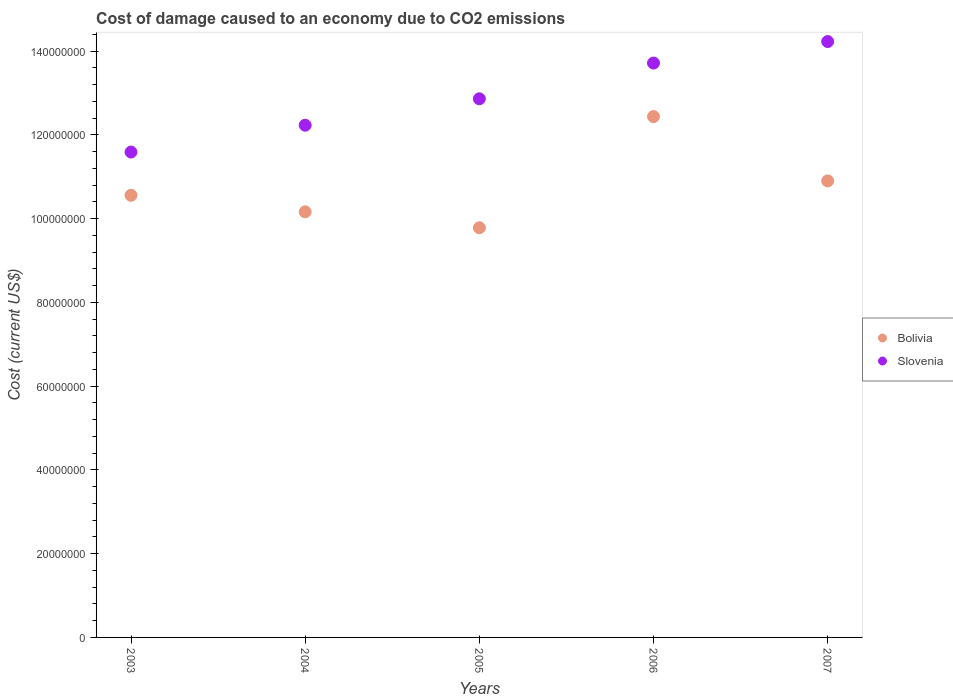How many different coloured dotlines are there?
Your response must be concise. 2. Is the number of dotlines equal to the number of legend labels?
Give a very brief answer. Yes. What is the cost of damage caused due to CO2 emissisons in Bolivia in 2006?
Provide a succinct answer. 1.24e+08. Across all years, what is the maximum cost of damage caused due to CO2 emissisons in Bolivia?
Provide a short and direct response. 1.24e+08. Across all years, what is the minimum cost of damage caused due to CO2 emissisons in Slovenia?
Your response must be concise. 1.16e+08. What is the total cost of damage caused due to CO2 emissisons in Slovenia in the graph?
Give a very brief answer. 6.46e+08. What is the difference between the cost of damage caused due to CO2 emissisons in Slovenia in 2005 and that in 2006?
Offer a very short reply. -8.53e+06. What is the difference between the cost of damage caused due to CO2 emissisons in Slovenia in 2006 and the cost of damage caused due to CO2 emissisons in Bolivia in 2005?
Ensure brevity in your answer.  3.93e+07. What is the average cost of damage caused due to CO2 emissisons in Bolivia per year?
Your answer should be very brief. 1.08e+08. In the year 2006, what is the difference between the cost of damage caused due to CO2 emissisons in Slovenia and cost of damage caused due to CO2 emissisons in Bolivia?
Ensure brevity in your answer.  1.28e+07. What is the ratio of the cost of damage caused due to CO2 emissisons in Bolivia in 2003 to that in 2004?
Provide a succinct answer. 1.04. Is the cost of damage caused due to CO2 emissisons in Bolivia in 2005 less than that in 2006?
Provide a succinct answer. Yes. What is the difference between the highest and the second highest cost of damage caused due to CO2 emissisons in Bolivia?
Make the answer very short. 1.54e+07. What is the difference between the highest and the lowest cost of damage caused due to CO2 emissisons in Slovenia?
Provide a short and direct response. 2.64e+07. In how many years, is the cost of damage caused due to CO2 emissisons in Slovenia greater than the average cost of damage caused due to CO2 emissisons in Slovenia taken over all years?
Your response must be concise. 2. Is the sum of the cost of damage caused due to CO2 emissisons in Slovenia in 2004 and 2007 greater than the maximum cost of damage caused due to CO2 emissisons in Bolivia across all years?
Make the answer very short. Yes. Does the cost of damage caused due to CO2 emissisons in Slovenia monotonically increase over the years?
Ensure brevity in your answer.  Yes. Is the cost of damage caused due to CO2 emissisons in Slovenia strictly greater than the cost of damage caused due to CO2 emissisons in Bolivia over the years?
Ensure brevity in your answer.  Yes. How many dotlines are there?
Offer a very short reply. 2. How many years are there in the graph?
Give a very brief answer. 5. What is the difference between two consecutive major ticks on the Y-axis?
Provide a succinct answer. 2.00e+07. Does the graph contain any zero values?
Your response must be concise. No. How are the legend labels stacked?
Your answer should be very brief. Vertical. What is the title of the graph?
Your answer should be compact. Cost of damage caused to an economy due to CO2 emissions. What is the label or title of the Y-axis?
Your response must be concise. Cost (current US$). What is the Cost (current US$) of Bolivia in 2003?
Your response must be concise. 1.06e+08. What is the Cost (current US$) of Slovenia in 2003?
Offer a very short reply. 1.16e+08. What is the Cost (current US$) of Bolivia in 2004?
Give a very brief answer. 1.02e+08. What is the Cost (current US$) of Slovenia in 2004?
Provide a short and direct response. 1.22e+08. What is the Cost (current US$) in Bolivia in 2005?
Provide a short and direct response. 9.78e+07. What is the Cost (current US$) in Slovenia in 2005?
Keep it short and to the point. 1.29e+08. What is the Cost (current US$) in Bolivia in 2006?
Ensure brevity in your answer.  1.24e+08. What is the Cost (current US$) in Slovenia in 2006?
Ensure brevity in your answer.  1.37e+08. What is the Cost (current US$) of Bolivia in 2007?
Your answer should be compact. 1.09e+08. What is the Cost (current US$) of Slovenia in 2007?
Offer a very short reply. 1.42e+08. Across all years, what is the maximum Cost (current US$) of Bolivia?
Your answer should be very brief. 1.24e+08. Across all years, what is the maximum Cost (current US$) in Slovenia?
Ensure brevity in your answer.  1.42e+08. Across all years, what is the minimum Cost (current US$) of Bolivia?
Provide a short and direct response. 9.78e+07. Across all years, what is the minimum Cost (current US$) in Slovenia?
Ensure brevity in your answer.  1.16e+08. What is the total Cost (current US$) of Bolivia in the graph?
Offer a terse response. 5.38e+08. What is the total Cost (current US$) of Slovenia in the graph?
Ensure brevity in your answer.  6.46e+08. What is the difference between the Cost (current US$) of Bolivia in 2003 and that in 2004?
Provide a succinct answer. 3.94e+06. What is the difference between the Cost (current US$) in Slovenia in 2003 and that in 2004?
Your answer should be very brief. -6.41e+06. What is the difference between the Cost (current US$) in Bolivia in 2003 and that in 2005?
Keep it short and to the point. 7.74e+06. What is the difference between the Cost (current US$) of Slovenia in 2003 and that in 2005?
Provide a short and direct response. -1.27e+07. What is the difference between the Cost (current US$) in Bolivia in 2003 and that in 2006?
Offer a very short reply. -1.88e+07. What is the difference between the Cost (current US$) in Slovenia in 2003 and that in 2006?
Offer a very short reply. -2.13e+07. What is the difference between the Cost (current US$) of Bolivia in 2003 and that in 2007?
Your answer should be compact. -3.44e+06. What is the difference between the Cost (current US$) of Slovenia in 2003 and that in 2007?
Your response must be concise. -2.64e+07. What is the difference between the Cost (current US$) in Bolivia in 2004 and that in 2005?
Offer a terse response. 3.80e+06. What is the difference between the Cost (current US$) in Slovenia in 2004 and that in 2005?
Your answer should be compact. -6.31e+06. What is the difference between the Cost (current US$) in Bolivia in 2004 and that in 2006?
Offer a very short reply. -2.27e+07. What is the difference between the Cost (current US$) in Slovenia in 2004 and that in 2006?
Keep it short and to the point. -1.48e+07. What is the difference between the Cost (current US$) of Bolivia in 2004 and that in 2007?
Give a very brief answer. -7.38e+06. What is the difference between the Cost (current US$) of Slovenia in 2004 and that in 2007?
Give a very brief answer. -2.00e+07. What is the difference between the Cost (current US$) in Bolivia in 2005 and that in 2006?
Your answer should be very brief. -2.65e+07. What is the difference between the Cost (current US$) of Slovenia in 2005 and that in 2006?
Provide a succinct answer. -8.53e+06. What is the difference between the Cost (current US$) of Bolivia in 2005 and that in 2007?
Provide a short and direct response. -1.12e+07. What is the difference between the Cost (current US$) in Slovenia in 2005 and that in 2007?
Keep it short and to the point. -1.37e+07. What is the difference between the Cost (current US$) in Bolivia in 2006 and that in 2007?
Your answer should be very brief. 1.54e+07. What is the difference between the Cost (current US$) in Slovenia in 2006 and that in 2007?
Offer a terse response. -5.13e+06. What is the difference between the Cost (current US$) in Bolivia in 2003 and the Cost (current US$) in Slovenia in 2004?
Ensure brevity in your answer.  -1.67e+07. What is the difference between the Cost (current US$) in Bolivia in 2003 and the Cost (current US$) in Slovenia in 2005?
Give a very brief answer. -2.30e+07. What is the difference between the Cost (current US$) of Bolivia in 2003 and the Cost (current US$) of Slovenia in 2006?
Your answer should be very brief. -3.16e+07. What is the difference between the Cost (current US$) of Bolivia in 2003 and the Cost (current US$) of Slovenia in 2007?
Offer a terse response. -3.67e+07. What is the difference between the Cost (current US$) in Bolivia in 2004 and the Cost (current US$) in Slovenia in 2005?
Make the answer very short. -2.70e+07. What is the difference between the Cost (current US$) in Bolivia in 2004 and the Cost (current US$) in Slovenia in 2006?
Offer a very short reply. -3.55e+07. What is the difference between the Cost (current US$) in Bolivia in 2004 and the Cost (current US$) in Slovenia in 2007?
Ensure brevity in your answer.  -4.07e+07. What is the difference between the Cost (current US$) of Bolivia in 2005 and the Cost (current US$) of Slovenia in 2006?
Ensure brevity in your answer.  -3.93e+07. What is the difference between the Cost (current US$) in Bolivia in 2005 and the Cost (current US$) in Slovenia in 2007?
Keep it short and to the point. -4.45e+07. What is the difference between the Cost (current US$) in Bolivia in 2006 and the Cost (current US$) in Slovenia in 2007?
Offer a very short reply. -1.79e+07. What is the average Cost (current US$) of Bolivia per year?
Offer a terse response. 1.08e+08. What is the average Cost (current US$) of Slovenia per year?
Give a very brief answer. 1.29e+08. In the year 2003, what is the difference between the Cost (current US$) of Bolivia and Cost (current US$) of Slovenia?
Offer a terse response. -1.03e+07. In the year 2004, what is the difference between the Cost (current US$) in Bolivia and Cost (current US$) in Slovenia?
Provide a short and direct response. -2.07e+07. In the year 2005, what is the difference between the Cost (current US$) in Bolivia and Cost (current US$) in Slovenia?
Offer a very short reply. -3.08e+07. In the year 2006, what is the difference between the Cost (current US$) in Bolivia and Cost (current US$) in Slovenia?
Give a very brief answer. -1.28e+07. In the year 2007, what is the difference between the Cost (current US$) in Bolivia and Cost (current US$) in Slovenia?
Provide a succinct answer. -3.33e+07. What is the ratio of the Cost (current US$) in Bolivia in 2003 to that in 2004?
Your answer should be compact. 1.04. What is the ratio of the Cost (current US$) in Slovenia in 2003 to that in 2004?
Your response must be concise. 0.95. What is the ratio of the Cost (current US$) of Bolivia in 2003 to that in 2005?
Provide a short and direct response. 1.08. What is the ratio of the Cost (current US$) of Slovenia in 2003 to that in 2005?
Your response must be concise. 0.9. What is the ratio of the Cost (current US$) of Bolivia in 2003 to that in 2006?
Your response must be concise. 0.85. What is the ratio of the Cost (current US$) in Slovenia in 2003 to that in 2006?
Keep it short and to the point. 0.84. What is the ratio of the Cost (current US$) in Bolivia in 2003 to that in 2007?
Keep it short and to the point. 0.97. What is the ratio of the Cost (current US$) of Slovenia in 2003 to that in 2007?
Provide a succinct answer. 0.81. What is the ratio of the Cost (current US$) in Bolivia in 2004 to that in 2005?
Keep it short and to the point. 1.04. What is the ratio of the Cost (current US$) in Slovenia in 2004 to that in 2005?
Provide a short and direct response. 0.95. What is the ratio of the Cost (current US$) of Bolivia in 2004 to that in 2006?
Your response must be concise. 0.82. What is the ratio of the Cost (current US$) in Slovenia in 2004 to that in 2006?
Your answer should be compact. 0.89. What is the ratio of the Cost (current US$) in Bolivia in 2004 to that in 2007?
Provide a succinct answer. 0.93. What is the ratio of the Cost (current US$) in Slovenia in 2004 to that in 2007?
Your response must be concise. 0.86. What is the ratio of the Cost (current US$) of Bolivia in 2005 to that in 2006?
Keep it short and to the point. 0.79. What is the ratio of the Cost (current US$) in Slovenia in 2005 to that in 2006?
Ensure brevity in your answer.  0.94. What is the ratio of the Cost (current US$) in Bolivia in 2005 to that in 2007?
Your answer should be very brief. 0.9. What is the ratio of the Cost (current US$) of Slovenia in 2005 to that in 2007?
Provide a short and direct response. 0.9. What is the ratio of the Cost (current US$) in Bolivia in 2006 to that in 2007?
Make the answer very short. 1.14. What is the ratio of the Cost (current US$) in Slovenia in 2006 to that in 2007?
Ensure brevity in your answer.  0.96. What is the difference between the highest and the second highest Cost (current US$) in Bolivia?
Keep it short and to the point. 1.54e+07. What is the difference between the highest and the second highest Cost (current US$) of Slovenia?
Offer a very short reply. 5.13e+06. What is the difference between the highest and the lowest Cost (current US$) of Bolivia?
Provide a succinct answer. 2.65e+07. What is the difference between the highest and the lowest Cost (current US$) in Slovenia?
Offer a terse response. 2.64e+07. 